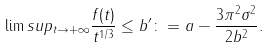Convert formula to latex. <formula><loc_0><loc_0><loc_500><loc_500>\lim s u p _ { t \to + \infty } \frac { f ( t ) } { t ^ { 1 / 3 } } \leq b ^ { \prime } \colon = a - \frac { 3 \pi ^ { 2 } \sigma ^ { 2 } } { 2 b ^ { 2 } } .</formula> 